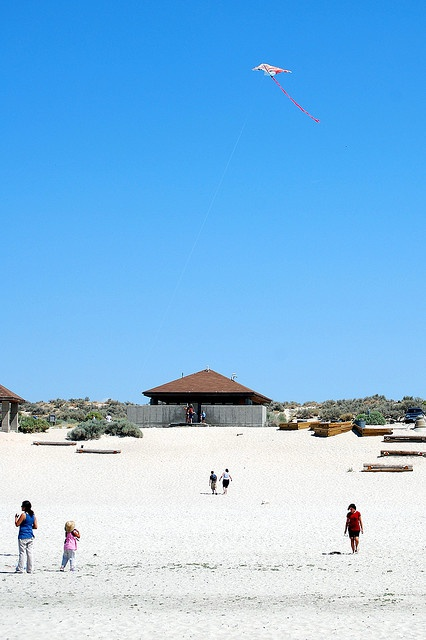Describe the objects in this image and their specific colors. I can see people in gray, lightgray, black, and darkgray tones, people in gray, black, white, maroon, and brown tones, people in gray, lavender, darkgray, and violet tones, kite in gray, lightblue, lightgray, and darkgray tones, and people in gray, white, black, and darkgray tones in this image. 